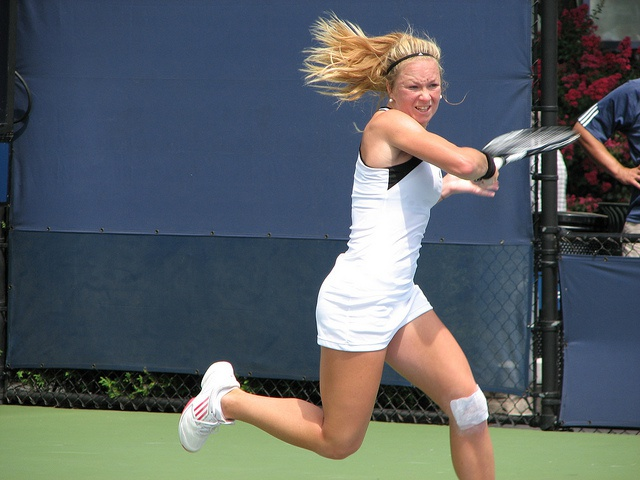Describe the objects in this image and their specific colors. I can see people in black, white, gray, and tan tones, people in black, navy, gray, and darkblue tones, and tennis racket in black, darkgray, lightgray, and gray tones in this image. 